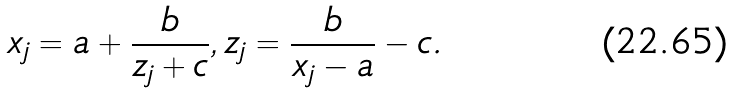Convert formula to latex. <formula><loc_0><loc_0><loc_500><loc_500>x _ { j } = a + \frac { b } { z _ { j } + c } , z _ { j } = \frac { b } { x _ { j } - a } - c .</formula> 